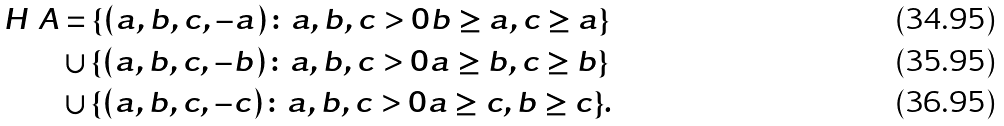<formula> <loc_0><loc_0><loc_500><loc_500>H \ A & = \{ ( a , b , c , - a ) \colon a , b , c > 0 b \geq a , c \geq a \} \\ & \cup \{ ( a , b , c , - b ) \colon a , b , c > 0 a \geq b , c \geq b \} \\ & \cup \{ ( a , b , c , - c ) \colon a , b , c > 0 a \geq c , b \geq c \} .</formula> 